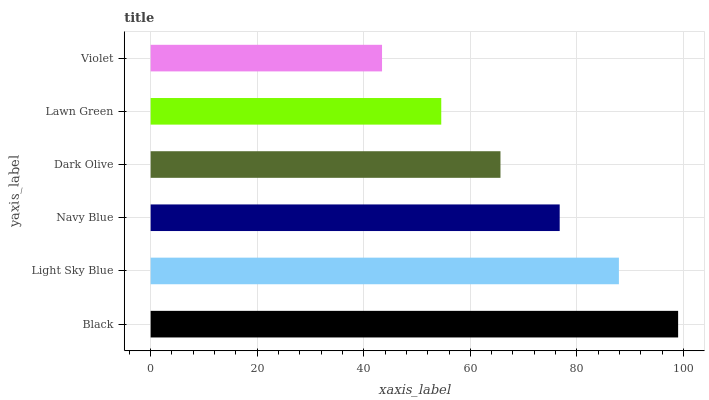Is Violet the minimum?
Answer yes or no. Yes. Is Black the maximum?
Answer yes or no. Yes. Is Light Sky Blue the minimum?
Answer yes or no. No. Is Light Sky Blue the maximum?
Answer yes or no. No. Is Black greater than Light Sky Blue?
Answer yes or no. Yes. Is Light Sky Blue less than Black?
Answer yes or no. Yes. Is Light Sky Blue greater than Black?
Answer yes or no. No. Is Black less than Light Sky Blue?
Answer yes or no. No. Is Navy Blue the high median?
Answer yes or no. Yes. Is Dark Olive the low median?
Answer yes or no. Yes. Is Violet the high median?
Answer yes or no. No. Is Lawn Green the low median?
Answer yes or no. No. 